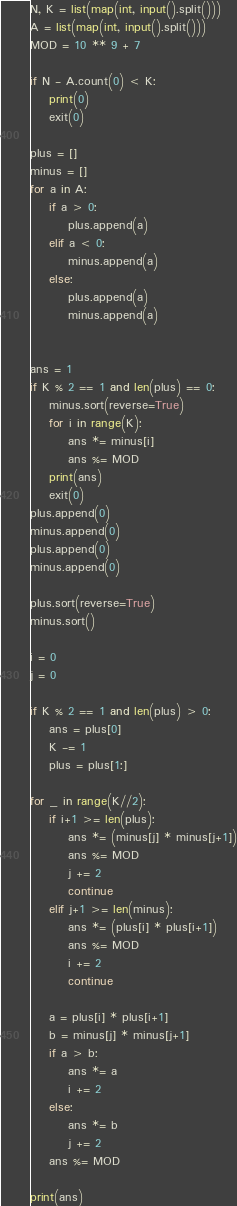<code> <loc_0><loc_0><loc_500><loc_500><_Python_>N, K = list(map(int, input().split()))
A = list(map(int, input().split()))
MOD = 10 ** 9 + 7

if N - A.count(0) < K:
    print(0)
    exit(0)

plus = []
minus = []
for a in A:
    if a > 0:
        plus.append(a)
    elif a < 0:
        minus.append(a)
    else:
        plus.append(a)
        minus.append(a)


ans = 1
if K % 2 == 1 and len(plus) == 0:
    minus.sort(reverse=True)
    for i in range(K):
        ans *= minus[i]
        ans %= MOD
    print(ans)
    exit(0)
plus.append(0)
minus.append(0)
plus.append(0)
minus.append(0)

plus.sort(reverse=True)
minus.sort()

i = 0
j = 0

if K % 2 == 1 and len(plus) > 0:
    ans = plus[0]
    K -= 1
    plus = plus[1:]

for _ in range(K//2):
    if i+1 >= len(plus):
        ans *= (minus[j] * minus[j+1])
        ans %= MOD
        j += 2
        continue
    elif j+1 >= len(minus):
        ans *= (plus[i] * plus[i+1])
        ans %= MOD
        i += 2
        continue

    a = plus[i] * plus[i+1]
    b = minus[j] * minus[j+1]
    if a > b:
        ans *= a
        i += 2
    else:
        ans *= b
        j += 2
    ans %= MOD

print(ans)
</code> 